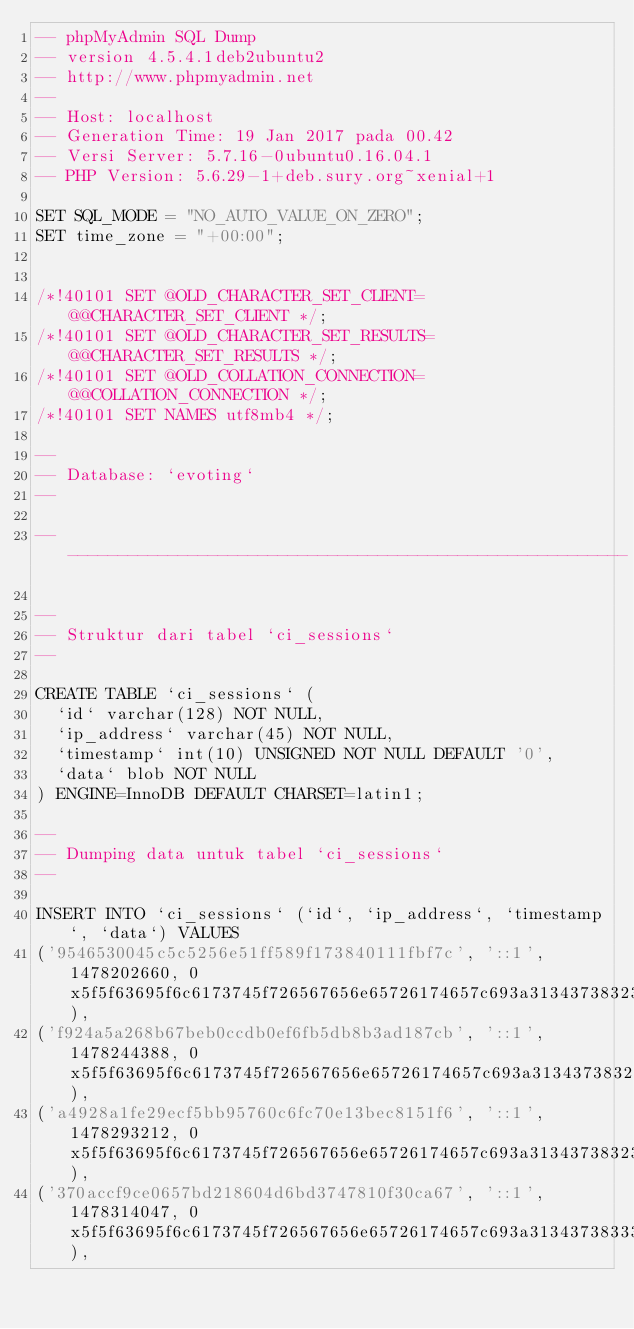Convert code to text. <code><loc_0><loc_0><loc_500><loc_500><_SQL_>-- phpMyAdmin SQL Dump
-- version 4.5.4.1deb2ubuntu2
-- http://www.phpmyadmin.net
--
-- Host: localhost
-- Generation Time: 19 Jan 2017 pada 00.42
-- Versi Server: 5.7.16-0ubuntu0.16.04.1
-- PHP Version: 5.6.29-1+deb.sury.org~xenial+1

SET SQL_MODE = "NO_AUTO_VALUE_ON_ZERO";
SET time_zone = "+00:00";


/*!40101 SET @OLD_CHARACTER_SET_CLIENT=@@CHARACTER_SET_CLIENT */;
/*!40101 SET @OLD_CHARACTER_SET_RESULTS=@@CHARACTER_SET_RESULTS */;
/*!40101 SET @OLD_COLLATION_CONNECTION=@@COLLATION_CONNECTION */;
/*!40101 SET NAMES utf8mb4 */;

--
-- Database: `evoting`
--

-- --------------------------------------------------------

--
-- Struktur dari tabel `ci_sessions`
--

CREATE TABLE `ci_sessions` (
  `id` varchar(128) NOT NULL,
  `ip_address` varchar(45) NOT NULL,
  `timestamp` int(10) UNSIGNED NOT NULL DEFAULT '0',
  `data` blob NOT NULL
) ENGINE=InnoDB DEFAULT CHARSET=latin1;

--
-- Dumping data untuk tabel `ci_sessions`
--

INSERT INTO `ci_sessions` (`id`, `ip_address`, `timestamp`, `data`) VALUES
('9546530045c5c5256e51ff589f173840111fbf7c', '::1', 1478202660, 0x5f5f63695f6c6173745f726567656e65726174657c693a313437383230323336373b6e69737c733a383a223230313631303932223b),
('f924a5a268b67beb0ccdb0ef6fb5db8b3ad187cb', '::1', 1478244388, 0x5f5f63695f6c6173745f726567656e65726174657c693a313437383234343338383b),
('a4928a1fe29ecf5bb95760c6fc70e13bec8151f6', '::1', 1478293212, 0x5f5f63695f6c6173745f726567656e65726174657c693a313437383239333139373b6e69737c733a383a223230313631303939223b),
('370accf9ce0657bd218604d6bd3747810f30ca67', '::1', 1478314047, 0x5f5f63695f6c6173745f726567656e65726174657c693a313437383331343030383b6e69737c733a383a223230313631313030223b),</code> 